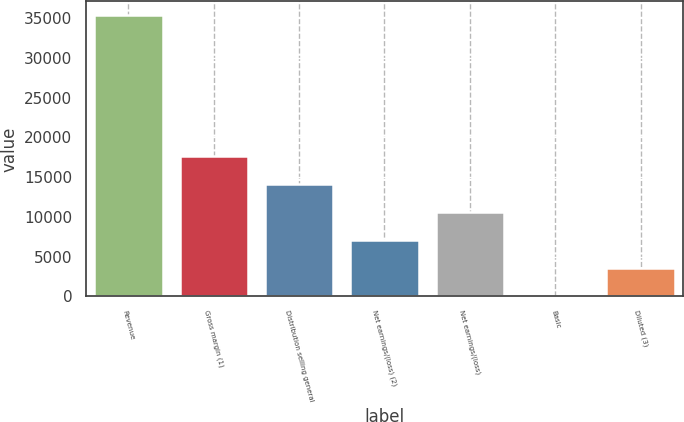<chart> <loc_0><loc_0><loc_500><loc_500><bar_chart><fcel>Revenue<fcel>Gross margin (1)<fcel>Distribution selling general<fcel>Net earnings/(loss) (2)<fcel>Net earnings/(loss)<fcel>Basic<fcel>Diluted (3)<nl><fcel>35349<fcel>17676.4<fcel>14141.8<fcel>7072.8<fcel>10607.3<fcel>3.76<fcel>3538.28<nl></chart> 